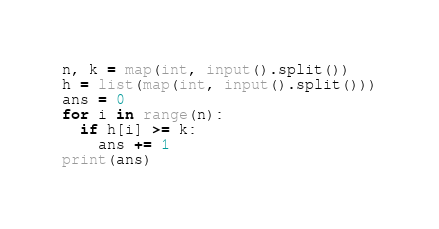<code> <loc_0><loc_0><loc_500><loc_500><_Python_>n, k = map(int, input().split())
h = list(map(int, input().split()))
ans = 0
for i in range(n):
  if h[i] >= k:
    ans += 1
print(ans)</code> 